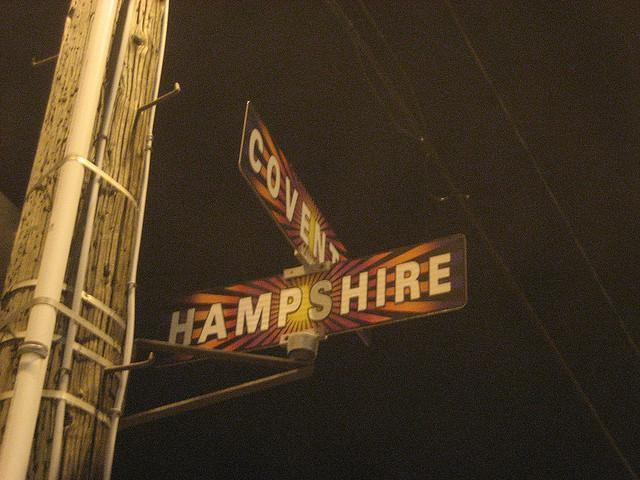How many signs are there?
Give a very brief answer. 2. 